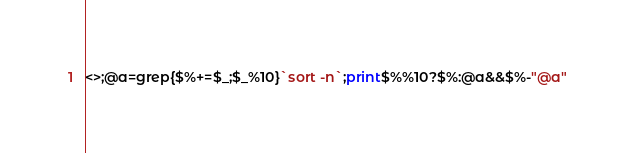<code> <loc_0><loc_0><loc_500><loc_500><_Perl_><>;@a=grep{$%+=$_;$_%10}`sort -n`;print$%%10?$%:@a&&$%-"@a"</code> 